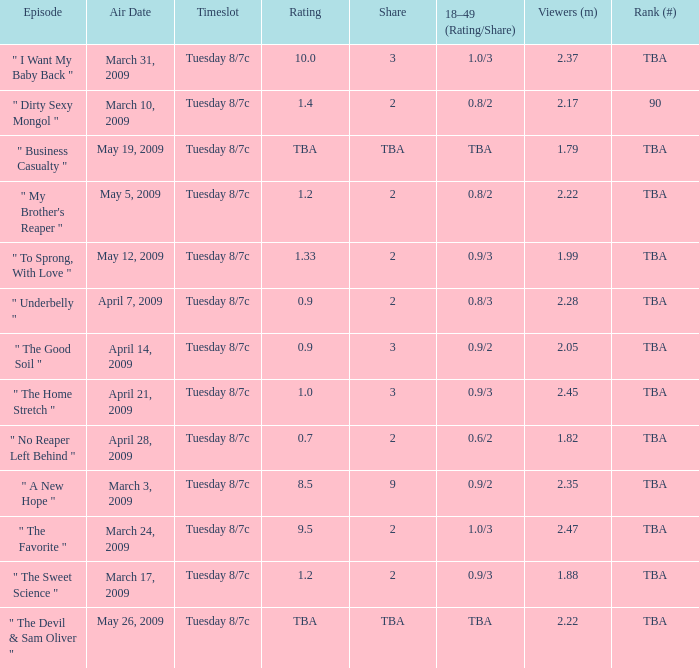What is the rating of the show ranked tba, aired on April 21, 2009? 1.0. 